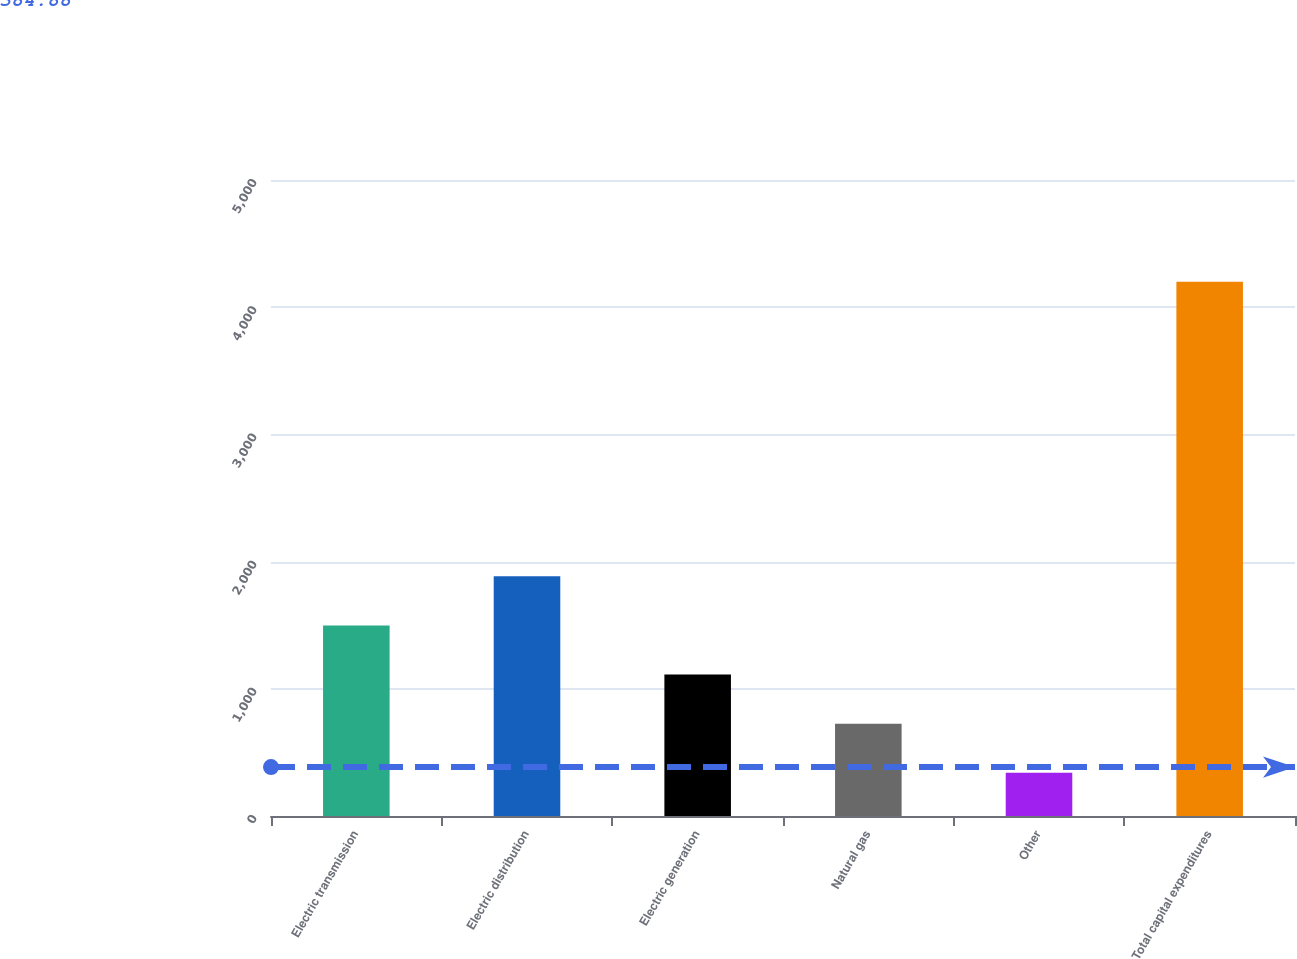Convert chart to OTSL. <chart><loc_0><loc_0><loc_500><loc_500><bar_chart><fcel>Electric transmission<fcel>Electric distribution<fcel>Electric generation<fcel>Natural gas<fcel>Other<fcel>Total capital expenditures<nl><fcel>1498<fcel>1884<fcel>1112<fcel>726<fcel>340<fcel>4200<nl></chart> 